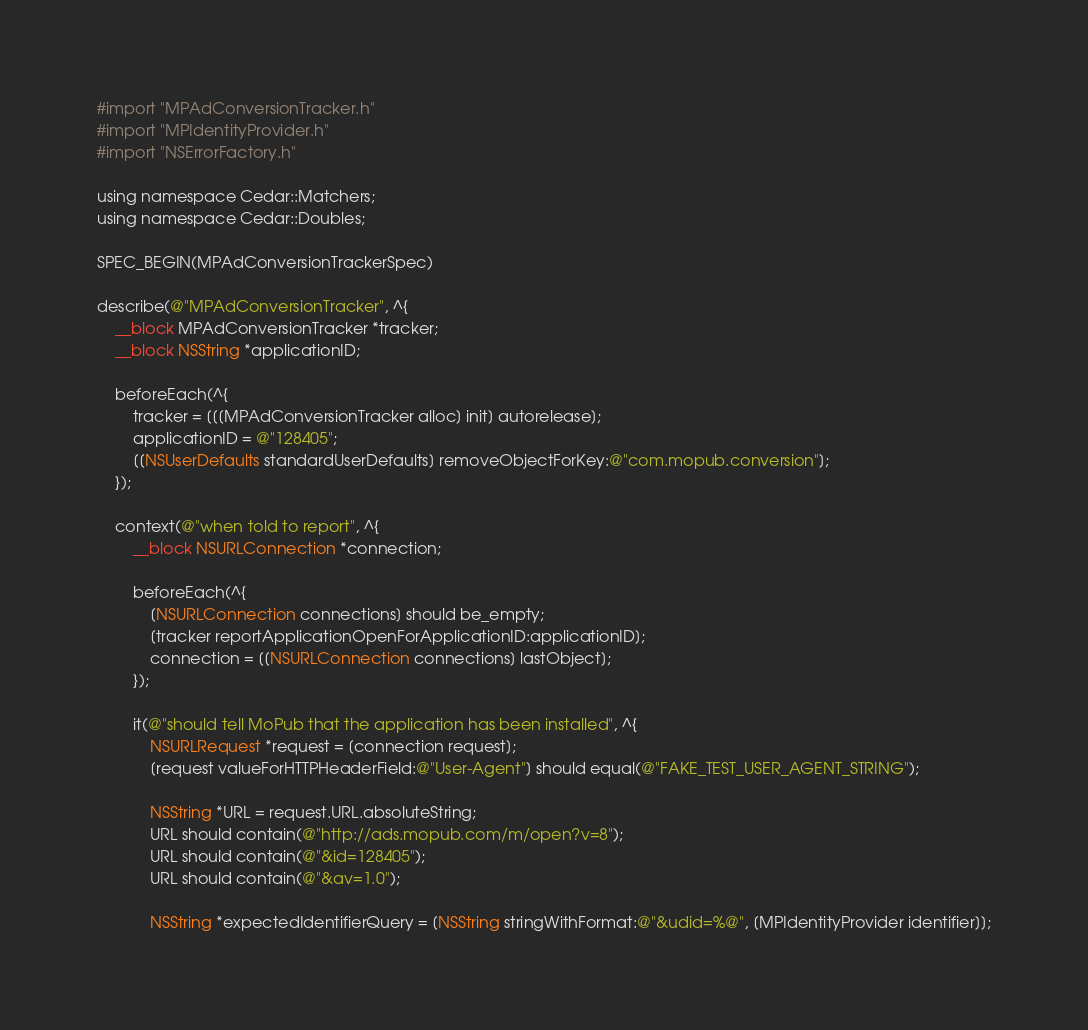<code> <loc_0><loc_0><loc_500><loc_500><_ObjectiveC_>#import "MPAdConversionTracker.h"
#import "MPIdentityProvider.h"
#import "NSErrorFactory.h"

using namespace Cedar::Matchers;
using namespace Cedar::Doubles;

SPEC_BEGIN(MPAdConversionTrackerSpec)

describe(@"MPAdConversionTracker", ^{
    __block MPAdConversionTracker *tracker;
    __block NSString *applicationID;

    beforeEach(^{
        tracker = [[[MPAdConversionTracker alloc] init] autorelease];
        applicationID = @"128405";
        [[NSUserDefaults standardUserDefaults] removeObjectForKey:@"com.mopub.conversion"];
    });

    context(@"when told to report", ^{
        __block NSURLConnection *connection;

        beforeEach(^{
            [NSURLConnection connections] should be_empty;
            [tracker reportApplicationOpenForApplicationID:applicationID];
            connection = [[NSURLConnection connections] lastObject];
        });

        it(@"should tell MoPub that the application has been installed", ^{
            NSURLRequest *request = [connection request];
            [request valueForHTTPHeaderField:@"User-Agent"] should equal(@"FAKE_TEST_USER_AGENT_STRING");

            NSString *URL = request.URL.absoluteString;
            URL should contain(@"http://ads.mopub.com/m/open?v=8");
            URL should contain(@"&id=128405");
            URL should contain(@"&av=1.0");

            NSString *expectedIdentifierQuery = [NSString stringWithFormat:@"&udid=%@", [MPIdentityProvider identifier]];</code> 